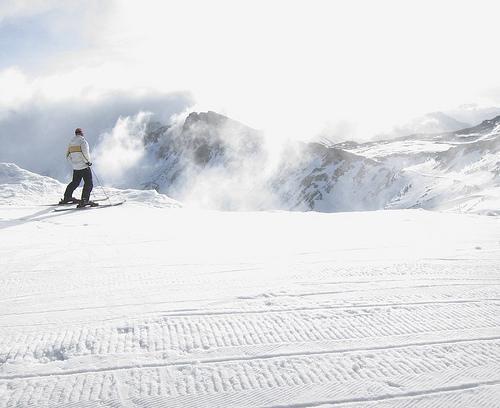How many people are in this scene?
Give a very brief answer. 1. 